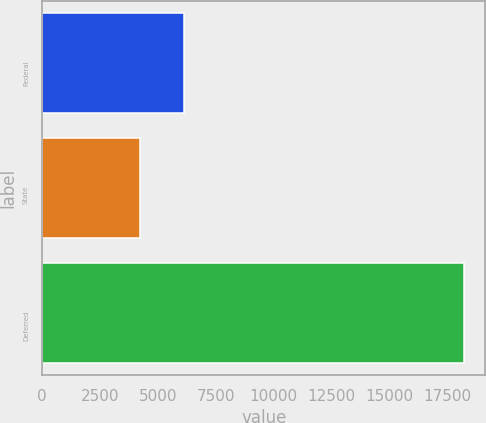Convert chart to OTSL. <chart><loc_0><loc_0><loc_500><loc_500><bar_chart><fcel>Federal<fcel>State<fcel>Deferred<nl><fcel>6151<fcel>4226<fcel>18243<nl></chart> 